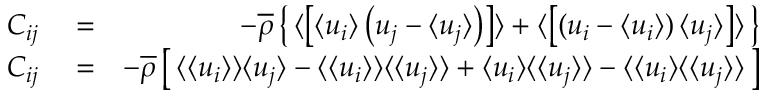Convert formula to latex. <formula><loc_0><loc_0><loc_500><loc_500>\begin{array} { r l r } { C _ { i j } } & = } & { - \overline { \rho } \left \{ \, \langle \left [ { \langle u _ { i } \rangle \left ( u _ { j } - \langle u _ { j } \rangle \right ) } \right ] \rangle + \langle \left [ { \left ( u _ { i } - \langle u _ { i } \rangle \right ) \langle u _ { j } \rangle } \right ] \rangle \, \right \} } \\ { C _ { i j } } & = } & { - \overline { \rho } \left [ \, \langle \langle u _ { i } \rangle \rangle \langle u _ { j } \rangle - \langle \langle u _ { i } \rangle \rangle \langle \langle u _ { j } \rangle \rangle + \langle u _ { i } \rangle \langle \langle u _ { j } \rangle \rangle - \langle \langle u _ { i } \rangle \langle \langle u _ { j } \rangle \rangle \, \right ] } \end{array}</formula> 